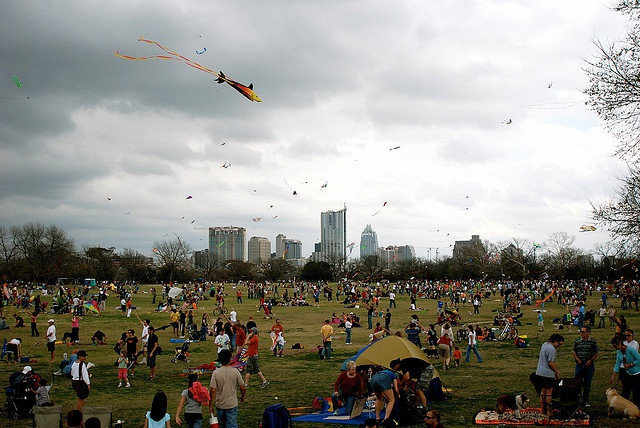Describe the objects in this image and their specific colors. I can see people in gray, black, olive, and maroon tones, people in gray and black tones, umbrella in gray, black, and olive tones, people in gray, black, maroon, and darkgreen tones, and people in gray, black, and maroon tones in this image. 